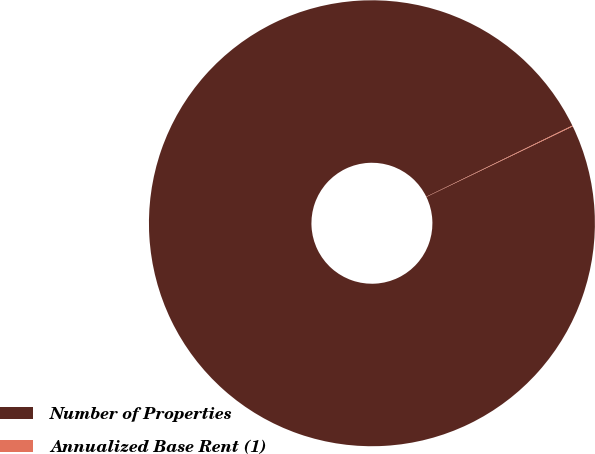Convert chart. <chart><loc_0><loc_0><loc_500><loc_500><pie_chart><fcel>Number of Properties<fcel>Annualized Base Rent (1)<nl><fcel>99.94%<fcel>0.06%<nl></chart> 